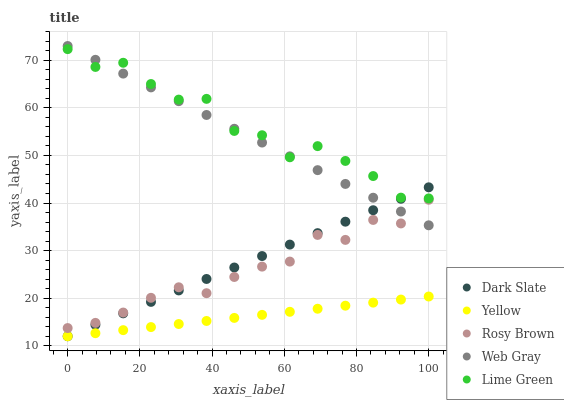Does Yellow have the minimum area under the curve?
Answer yes or no. Yes. Does Lime Green have the maximum area under the curve?
Answer yes or no. Yes. Does Dark Slate have the minimum area under the curve?
Answer yes or no. No. Does Dark Slate have the maximum area under the curve?
Answer yes or no. No. Is Dark Slate the smoothest?
Answer yes or no. Yes. Is Lime Green the roughest?
Answer yes or no. Yes. Is Rosy Brown the smoothest?
Answer yes or no. No. Is Rosy Brown the roughest?
Answer yes or no. No. Does Dark Slate have the lowest value?
Answer yes or no. Yes. Does Rosy Brown have the lowest value?
Answer yes or no. No. Does Web Gray have the highest value?
Answer yes or no. Yes. Does Dark Slate have the highest value?
Answer yes or no. No. Is Rosy Brown less than Lime Green?
Answer yes or no. Yes. Is Lime Green greater than Rosy Brown?
Answer yes or no. Yes. Does Web Gray intersect Dark Slate?
Answer yes or no. Yes. Is Web Gray less than Dark Slate?
Answer yes or no. No. Is Web Gray greater than Dark Slate?
Answer yes or no. No. Does Rosy Brown intersect Lime Green?
Answer yes or no. No. 